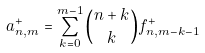Convert formula to latex. <formula><loc_0><loc_0><loc_500><loc_500>a ^ { + } _ { n , m } = \sum _ { k = 0 } ^ { m - 1 } { n + k \choose k } f ^ { + } _ { n , m - k - 1 }</formula> 